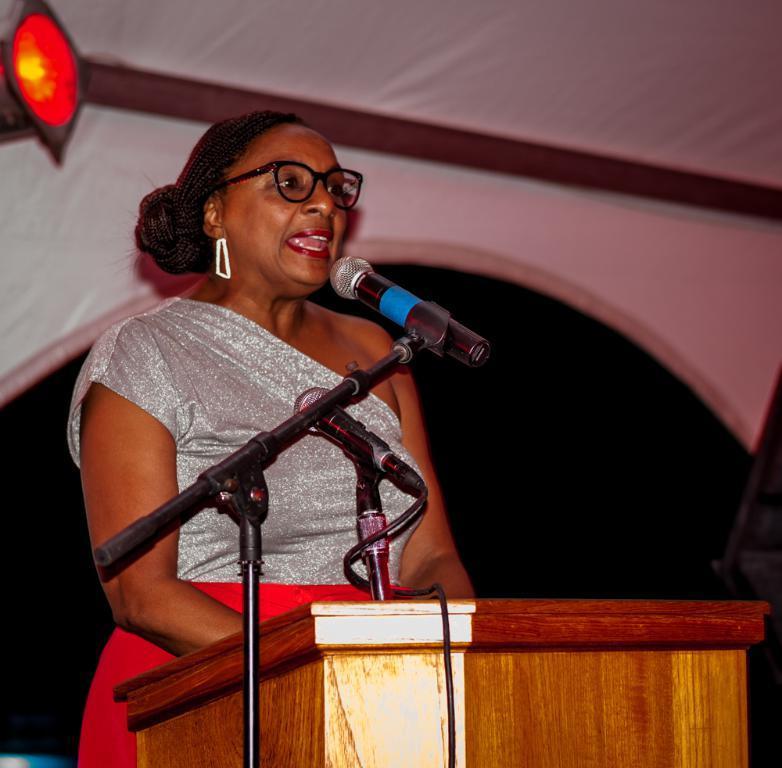In one or two sentences, can you explain what this image depicts? In this image we can see a woman standing at the podium and mic in front of her. In the background we can see electric lights and walls. 